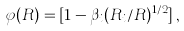<formula> <loc_0><loc_0><loc_500><loc_500>\varphi ( R ) = [ 1 - \beta _ { i } ( R _ { i } / R ) ^ { 1 / 2 } ] \, ,</formula> 